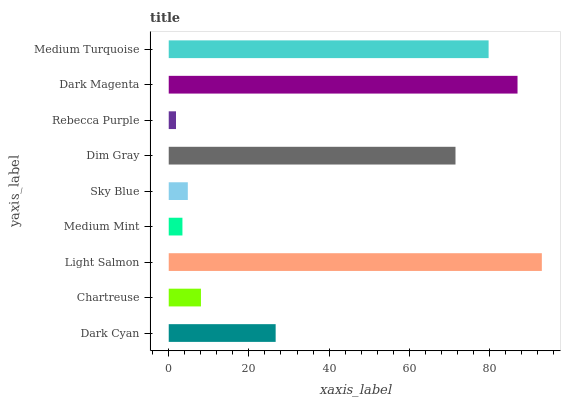Is Rebecca Purple the minimum?
Answer yes or no. Yes. Is Light Salmon the maximum?
Answer yes or no. Yes. Is Chartreuse the minimum?
Answer yes or no. No. Is Chartreuse the maximum?
Answer yes or no. No. Is Dark Cyan greater than Chartreuse?
Answer yes or no. Yes. Is Chartreuse less than Dark Cyan?
Answer yes or no. Yes. Is Chartreuse greater than Dark Cyan?
Answer yes or no. No. Is Dark Cyan less than Chartreuse?
Answer yes or no. No. Is Dark Cyan the high median?
Answer yes or no. Yes. Is Dark Cyan the low median?
Answer yes or no. Yes. Is Medium Turquoise the high median?
Answer yes or no. No. Is Sky Blue the low median?
Answer yes or no. No. 